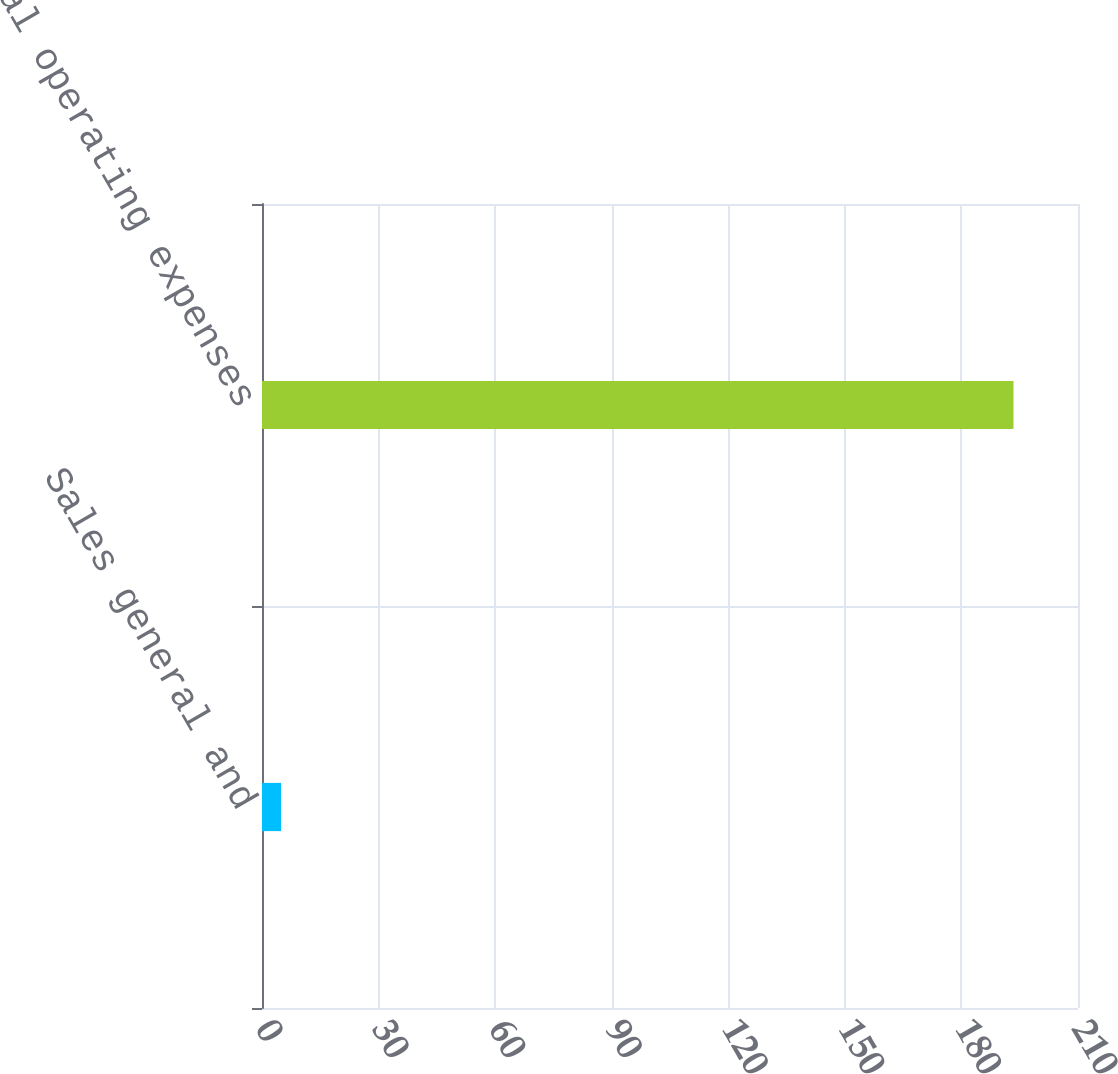<chart> <loc_0><loc_0><loc_500><loc_500><bar_chart><fcel>Sales general and<fcel>Total operating expenses<nl><fcel>4.9<fcel>193.4<nl></chart> 